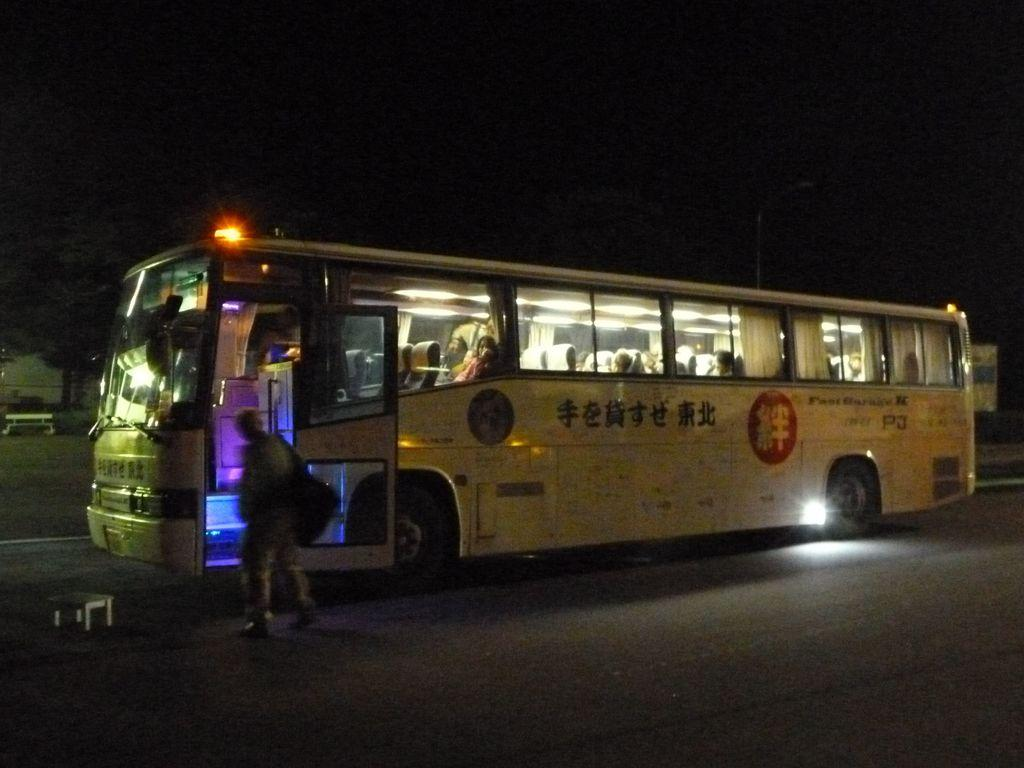Where was the image taken? The image was clicked outside. What is the main subject in the middle of the image? There is a bus in the middle of the image. What is the color of the bus? The bus is white in color. Can you tell if there are any passengers inside the bus? Yes, there are people inside the bus. Are there any fairies flying around the bus in the image? No, there are no fairies present in the image. 